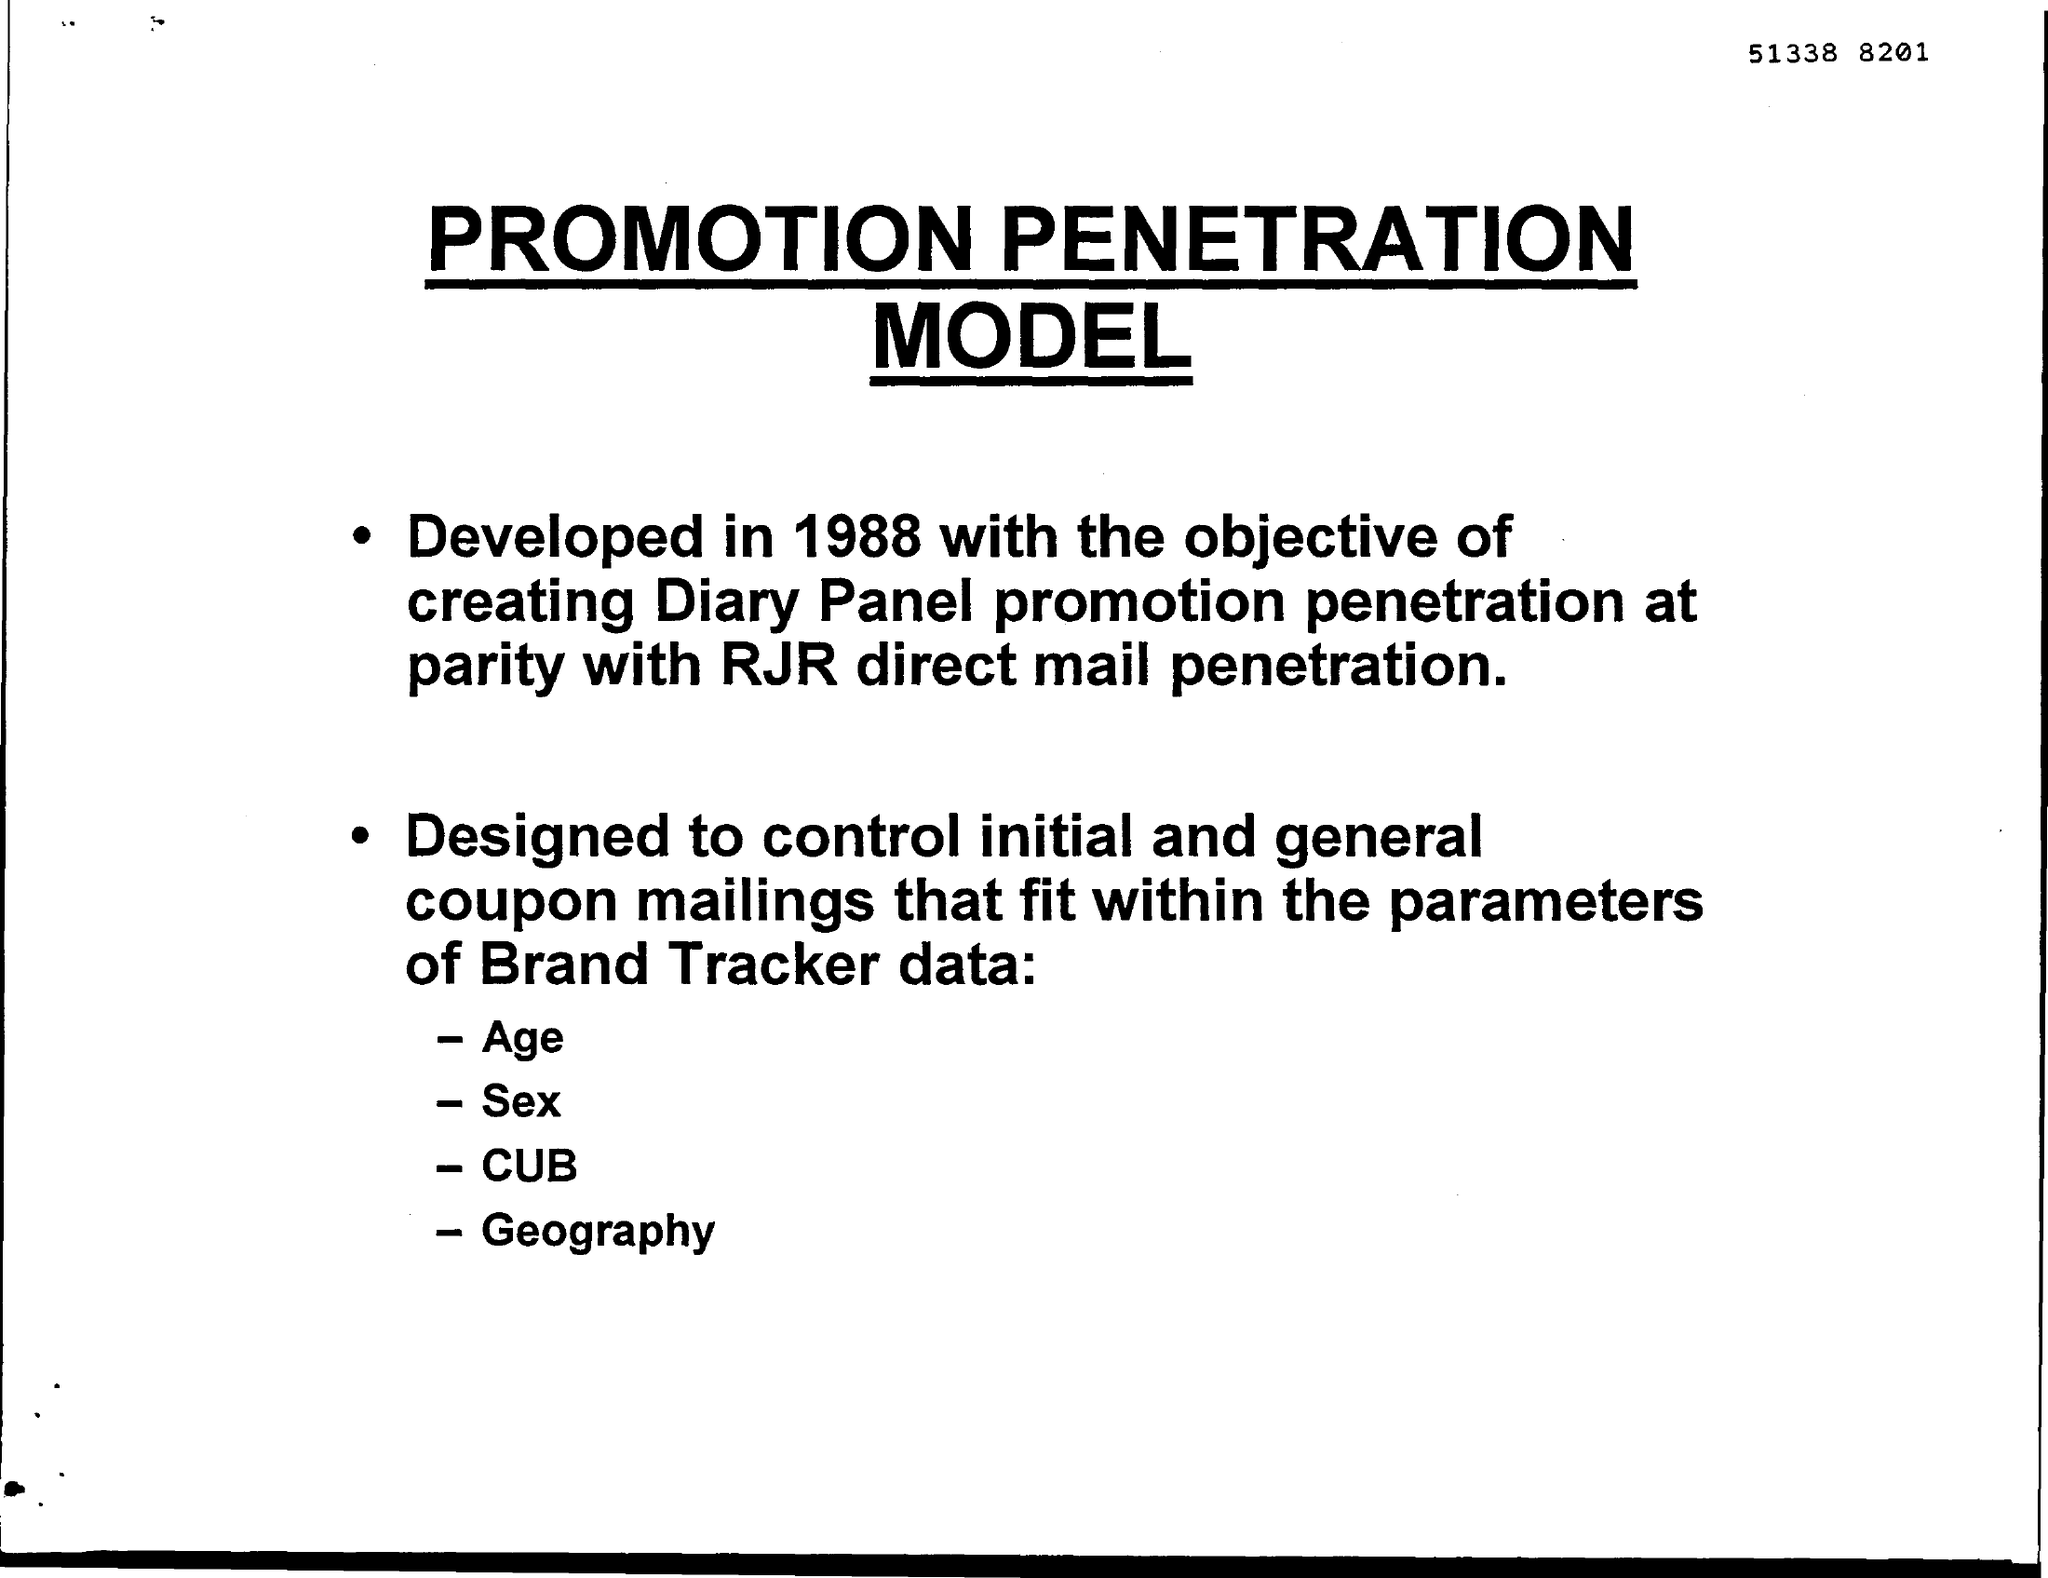What is the document title?
Offer a very short reply. PROMOTION PENETRATION MODEL. Which year was the model developed?
Ensure brevity in your answer.  1988. 